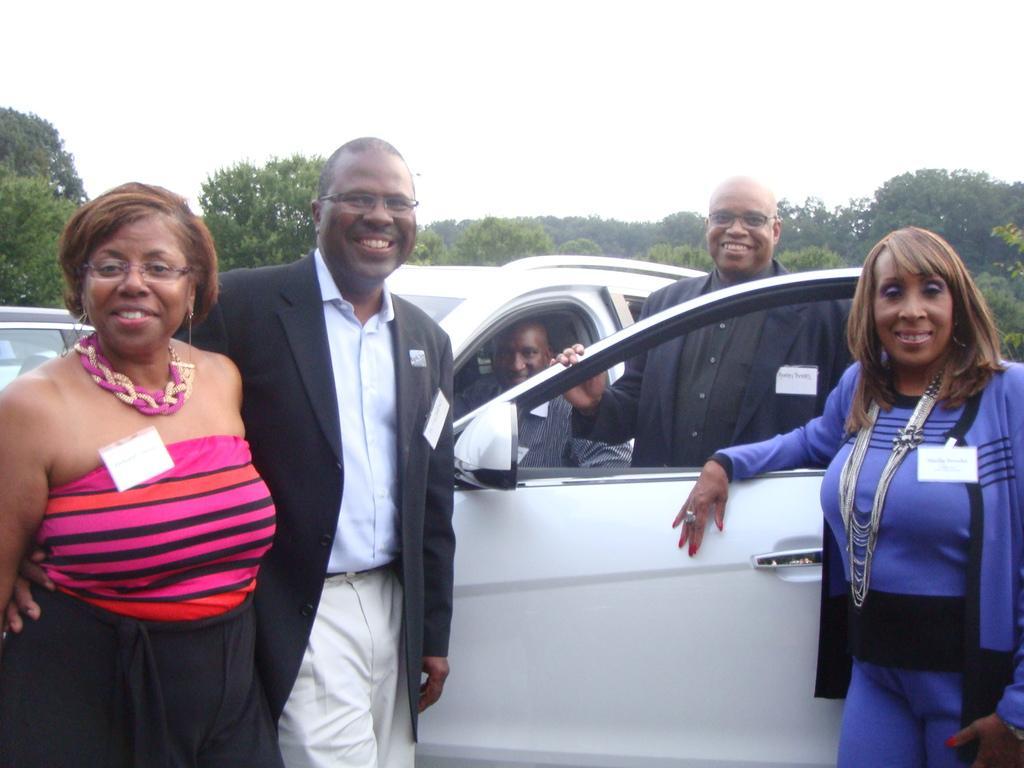How would you summarize this image in a sentence or two? This is a picture outside of a city. And back ground of the image there are some trees and sky. And a person sit on the car. Re maiming persons stand on the floor and there are smiling 